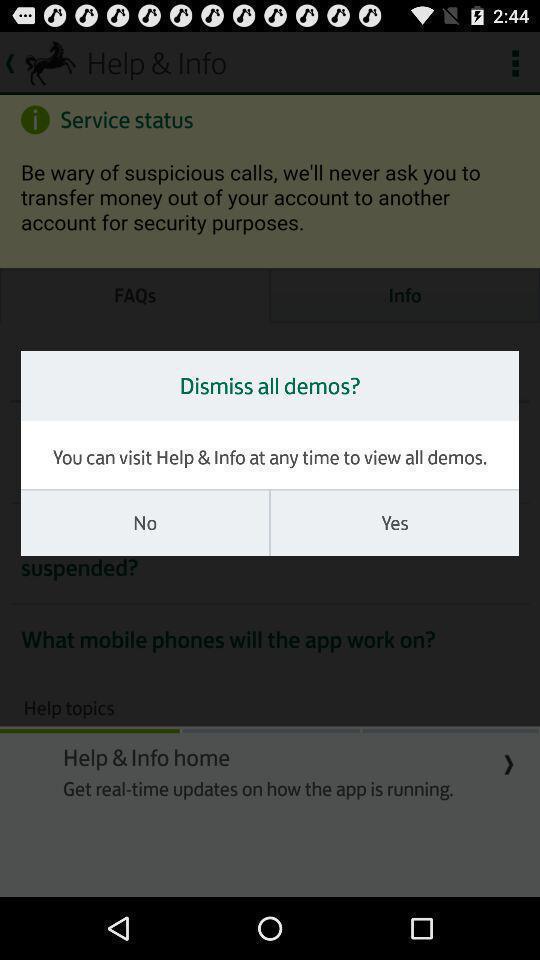Provide a detailed account of this screenshot. Pop up screen of dismiss all demos notification. 